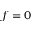<formula> <loc_0><loc_0><loc_500><loc_500>f = 0</formula> 